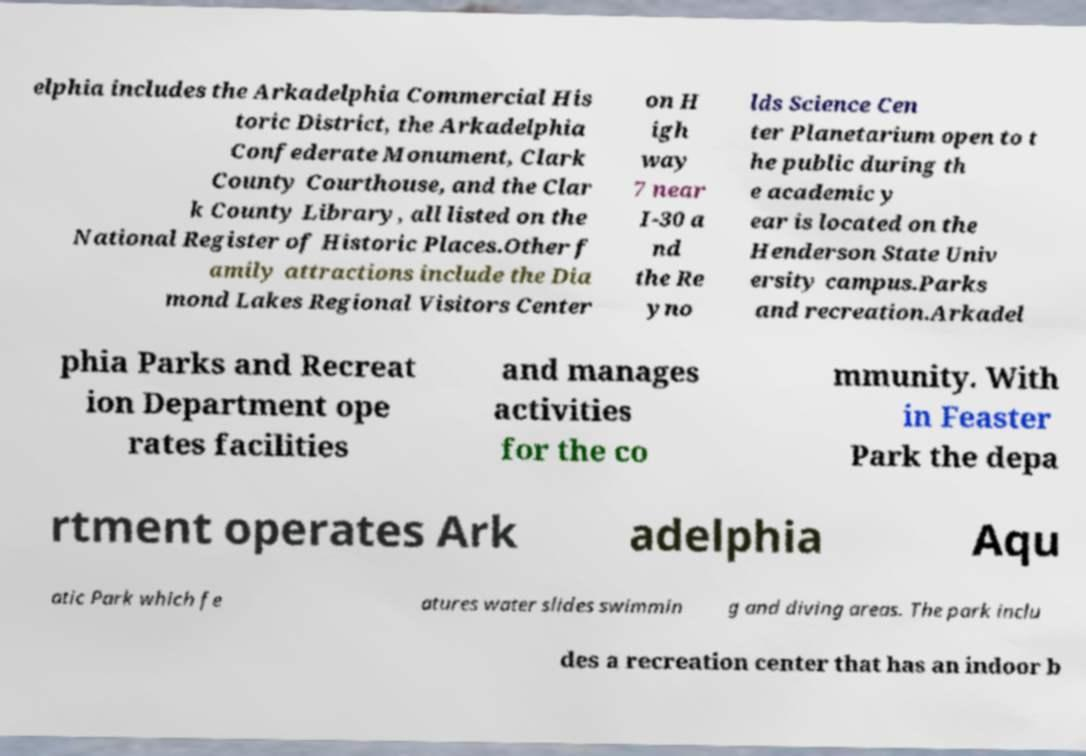Please read and relay the text visible in this image. What does it say? elphia includes the Arkadelphia Commercial His toric District, the Arkadelphia Confederate Monument, Clark County Courthouse, and the Clar k County Library, all listed on the National Register of Historic Places.Other f amily attractions include the Dia mond Lakes Regional Visitors Center on H igh way 7 near I-30 a nd the Re yno lds Science Cen ter Planetarium open to t he public during th e academic y ear is located on the Henderson State Univ ersity campus.Parks and recreation.Arkadel phia Parks and Recreat ion Department ope rates facilities and manages activities for the co mmunity. With in Feaster Park the depa rtment operates Ark adelphia Aqu atic Park which fe atures water slides swimmin g and diving areas. The park inclu des a recreation center that has an indoor b 